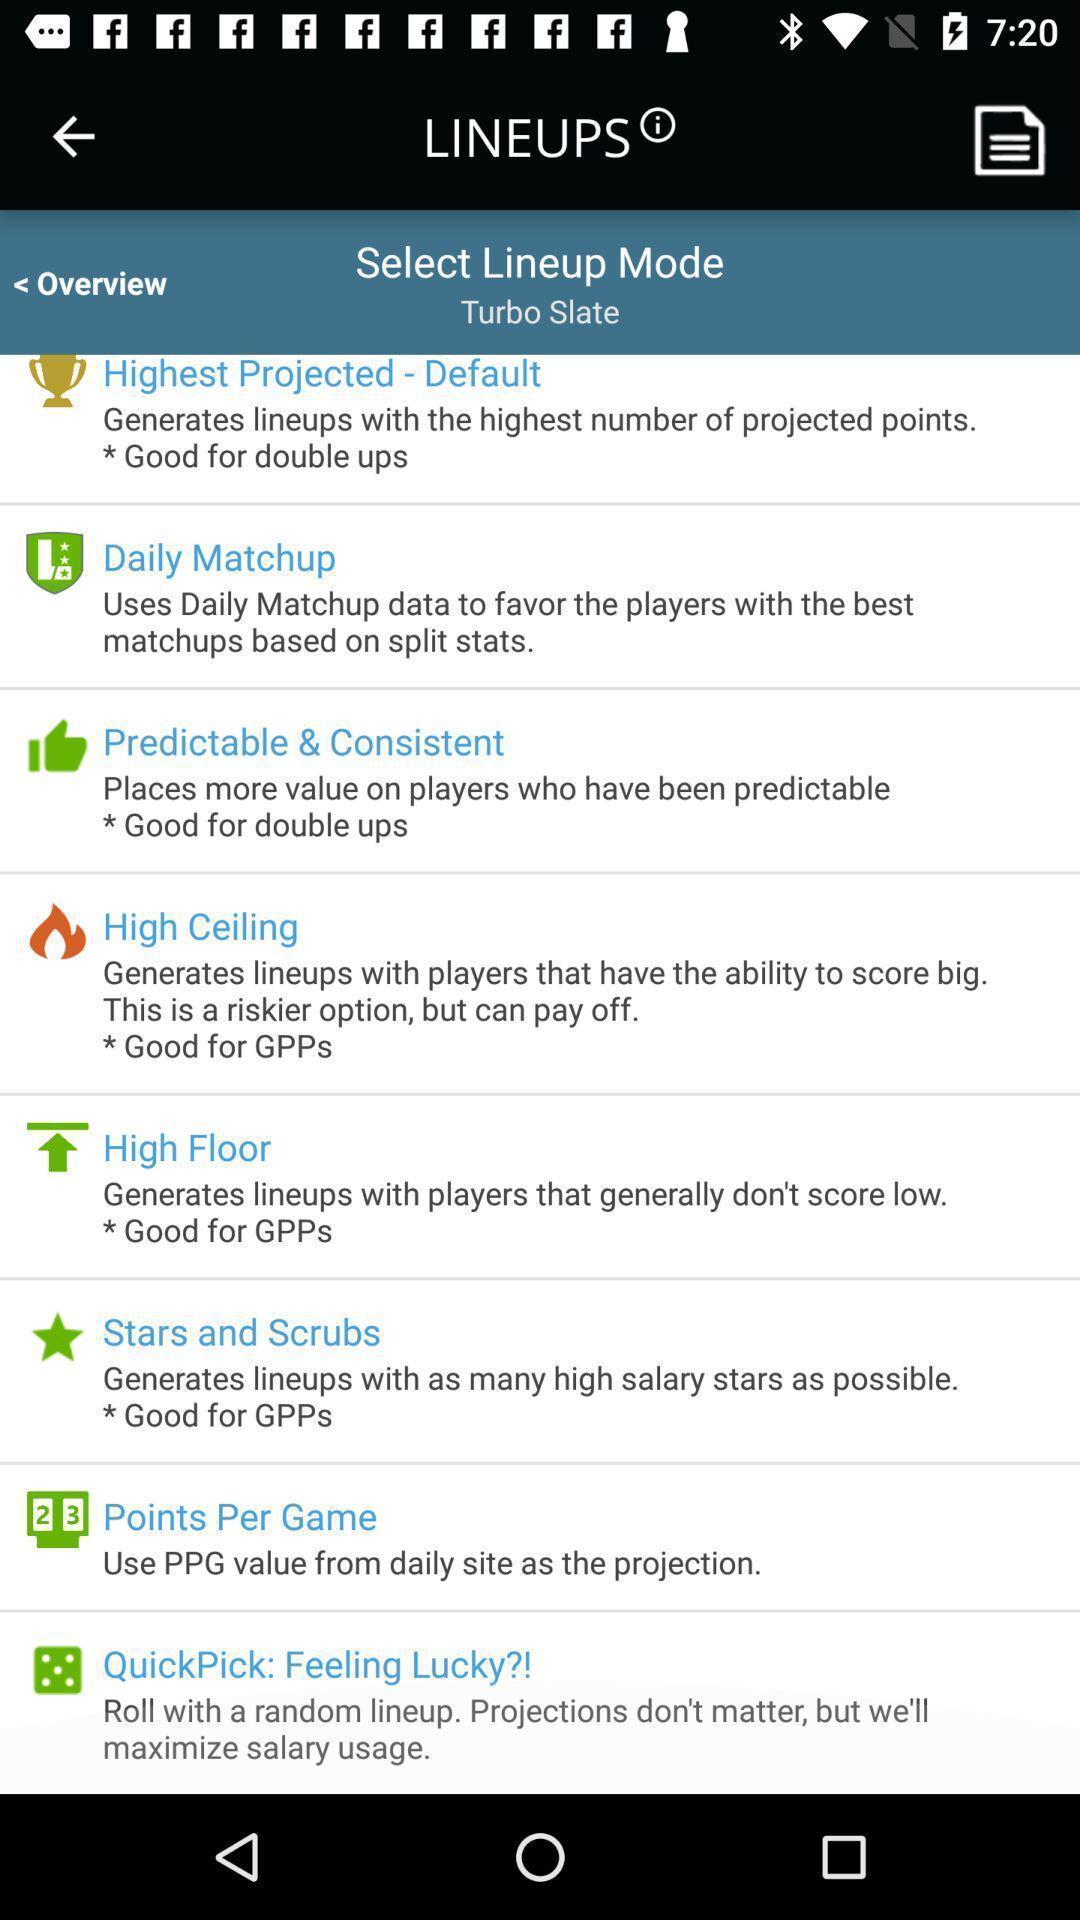Provide a detailed account of this screenshot. Screen displaying a list of modes with description. 